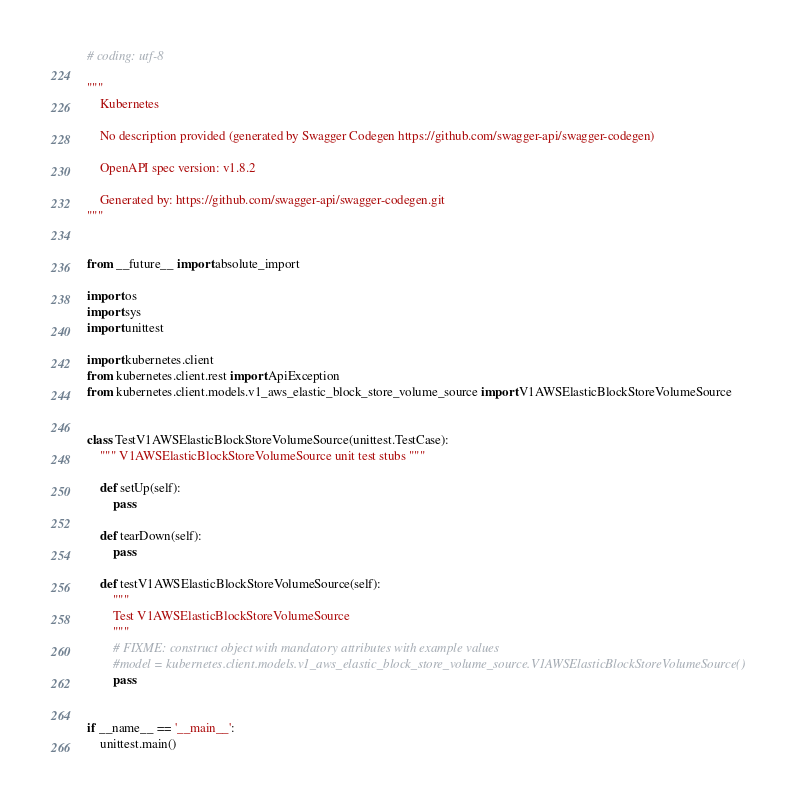<code> <loc_0><loc_0><loc_500><loc_500><_Python_># coding: utf-8

"""
    Kubernetes

    No description provided (generated by Swagger Codegen https://github.com/swagger-api/swagger-codegen)

    OpenAPI spec version: v1.8.2
    
    Generated by: https://github.com/swagger-api/swagger-codegen.git
"""


from __future__ import absolute_import

import os
import sys
import unittest

import kubernetes.client
from kubernetes.client.rest import ApiException
from kubernetes.client.models.v1_aws_elastic_block_store_volume_source import V1AWSElasticBlockStoreVolumeSource


class TestV1AWSElasticBlockStoreVolumeSource(unittest.TestCase):
    """ V1AWSElasticBlockStoreVolumeSource unit test stubs """

    def setUp(self):
        pass

    def tearDown(self):
        pass

    def testV1AWSElasticBlockStoreVolumeSource(self):
        """
        Test V1AWSElasticBlockStoreVolumeSource
        """
        # FIXME: construct object with mandatory attributes with example values
        #model = kubernetes.client.models.v1_aws_elastic_block_store_volume_source.V1AWSElasticBlockStoreVolumeSource()
        pass


if __name__ == '__main__':
    unittest.main()
</code> 